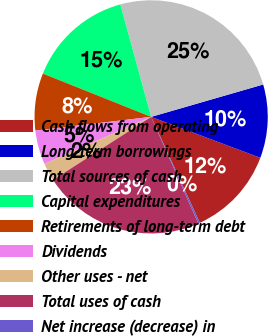Convert chart. <chart><loc_0><loc_0><loc_500><loc_500><pie_chart><fcel>Cash flows from operating<fcel>Long-term borrowings<fcel>Total sources of cash<fcel>Capital expenditures<fcel>Retirements of long-term debt<fcel>Dividends<fcel>Other uses - net<fcel>Total uses of cash<fcel>Net increase (decrease) in<nl><fcel>12.44%<fcel>10.18%<fcel>24.78%<fcel>14.69%<fcel>7.93%<fcel>4.74%<fcel>2.48%<fcel>22.53%<fcel>0.23%<nl></chart> 